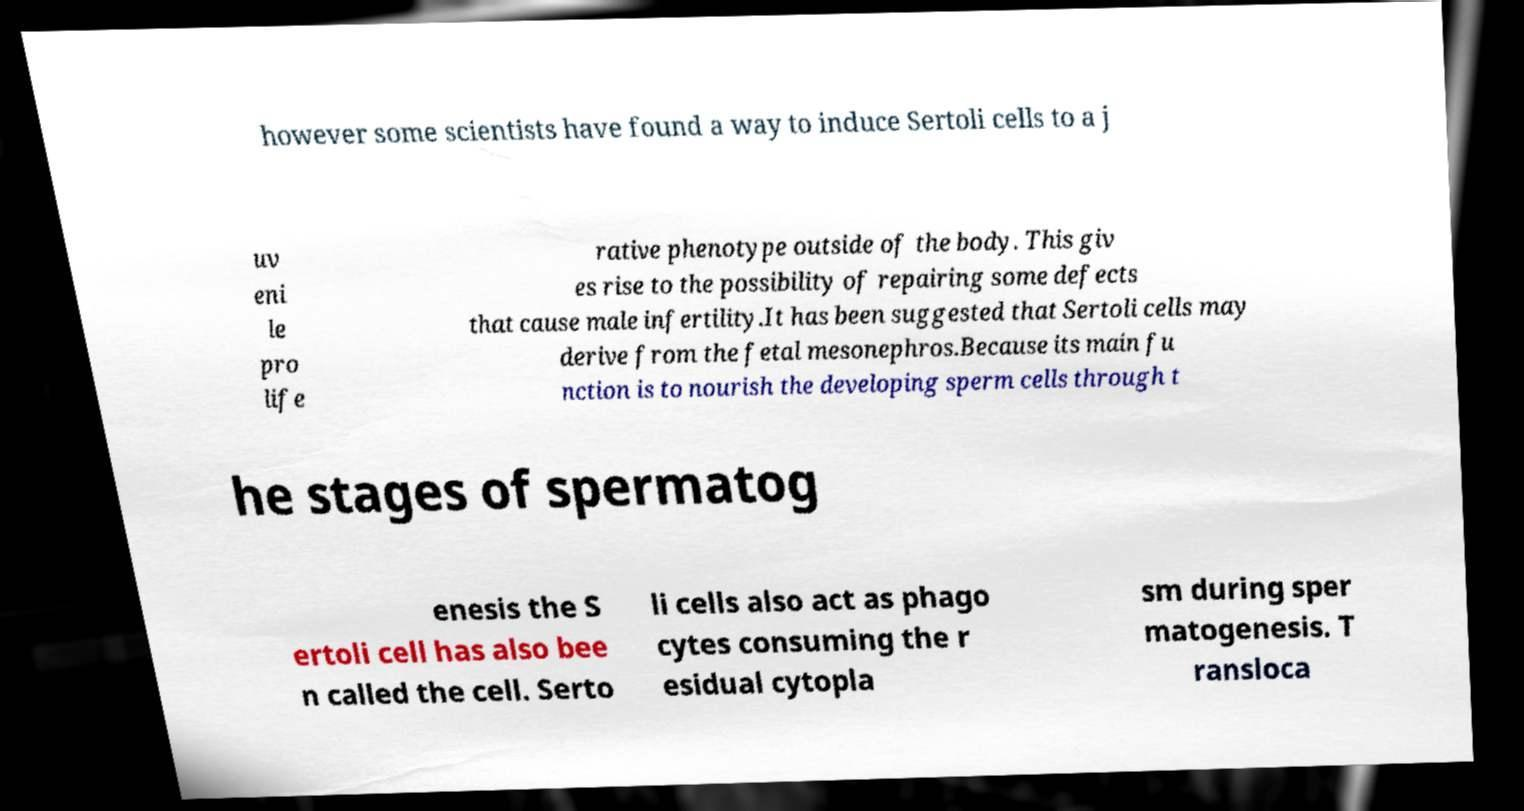There's text embedded in this image that I need extracted. Can you transcribe it verbatim? however some scientists have found a way to induce Sertoli cells to a j uv eni le pro life rative phenotype outside of the body. This giv es rise to the possibility of repairing some defects that cause male infertility.It has been suggested that Sertoli cells may derive from the fetal mesonephros.Because its main fu nction is to nourish the developing sperm cells through t he stages of spermatog enesis the S ertoli cell has also bee n called the cell. Serto li cells also act as phago cytes consuming the r esidual cytopla sm during sper matogenesis. T ransloca 